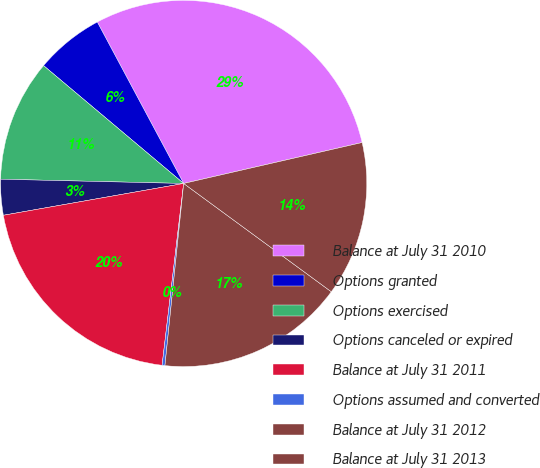<chart> <loc_0><loc_0><loc_500><loc_500><pie_chart><fcel>Balance at July 31 2010<fcel>Options granted<fcel>Options exercised<fcel>Options canceled or expired<fcel>Balance at July 31 2011<fcel>Options assumed and converted<fcel>Balance at July 31 2012<fcel>Balance at July 31 2013<nl><fcel>29.23%<fcel>6.05%<fcel>10.76%<fcel>3.15%<fcel>20.34%<fcel>0.25%<fcel>16.56%<fcel>13.66%<nl></chart> 